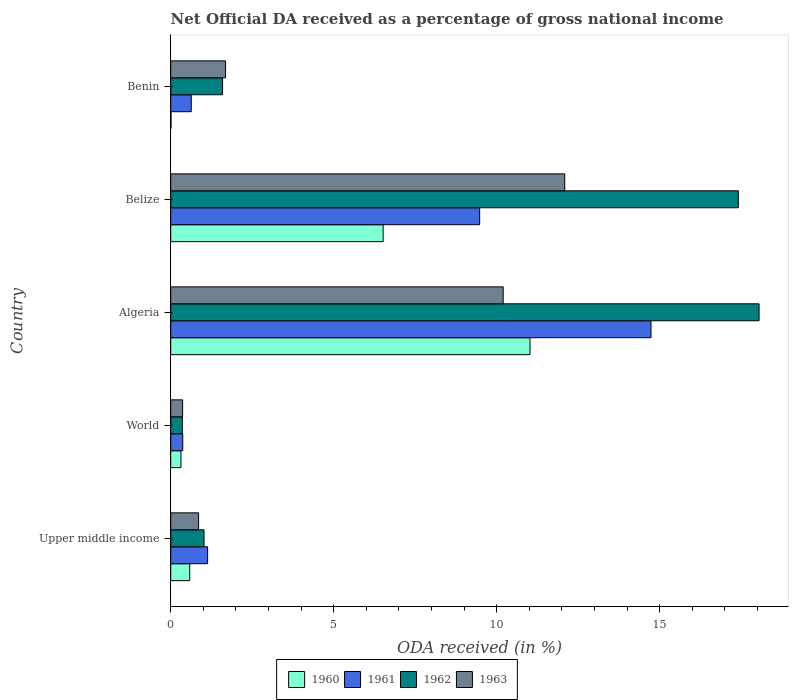How many different coloured bars are there?
Offer a terse response. 4. How many groups of bars are there?
Your response must be concise. 5. Are the number of bars on each tick of the Y-axis equal?
Provide a succinct answer. Yes. How many bars are there on the 3rd tick from the top?
Your response must be concise. 4. What is the label of the 2nd group of bars from the top?
Keep it short and to the point. Belize. What is the net official DA received in 1962 in Benin?
Make the answer very short. 1.59. Across all countries, what is the maximum net official DA received in 1963?
Ensure brevity in your answer.  12.09. Across all countries, what is the minimum net official DA received in 1961?
Offer a terse response. 0.37. In which country was the net official DA received in 1961 maximum?
Offer a terse response. Algeria. What is the total net official DA received in 1961 in the graph?
Your answer should be compact. 26.34. What is the difference between the net official DA received in 1960 in Upper middle income and that in World?
Make the answer very short. 0.27. What is the difference between the net official DA received in 1961 in Belize and the net official DA received in 1960 in Upper middle income?
Ensure brevity in your answer.  8.89. What is the average net official DA received in 1961 per country?
Give a very brief answer. 5.27. What is the difference between the net official DA received in 1962 and net official DA received in 1961 in World?
Offer a very short reply. -0.01. What is the ratio of the net official DA received in 1960 in Benin to that in World?
Keep it short and to the point. 0.03. Is the net official DA received in 1963 in Benin less than that in World?
Give a very brief answer. No. What is the difference between the highest and the second highest net official DA received in 1961?
Provide a short and direct response. 5.26. What is the difference between the highest and the lowest net official DA received in 1962?
Provide a succinct answer. 17.69. In how many countries, is the net official DA received in 1962 greater than the average net official DA received in 1962 taken over all countries?
Your answer should be compact. 2. Is the sum of the net official DA received in 1962 in Belize and World greater than the maximum net official DA received in 1963 across all countries?
Keep it short and to the point. Yes. Is it the case that in every country, the sum of the net official DA received in 1960 and net official DA received in 1962 is greater than the sum of net official DA received in 1961 and net official DA received in 1963?
Provide a succinct answer. No. What does the 1st bar from the top in World represents?
Give a very brief answer. 1963. Are all the bars in the graph horizontal?
Your response must be concise. Yes. How many countries are there in the graph?
Offer a terse response. 5. What is the difference between two consecutive major ticks on the X-axis?
Provide a short and direct response. 5. What is the title of the graph?
Your answer should be compact. Net Official DA received as a percentage of gross national income. What is the label or title of the X-axis?
Ensure brevity in your answer.  ODA received (in %). What is the ODA received (in %) in 1960 in Upper middle income?
Provide a short and direct response. 0.58. What is the ODA received (in %) in 1961 in Upper middle income?
Your answer should be very brief. 1.13. What is the ODA received (in %) of 1962 in Upper middle income?
Ensure brevity in your answer.  1.02. What is the ODA received (in %) of 1963 in Upper middle income?
Give a very brief answer. 0.86. What is the ODA received (in %) in 1960 in World?
Keep it short and to the point. 0.31. What is the ODA received (in %) in 1961 in World?
Your answer should be very brief. 0.37. What is the ODA received (in %) of 1962 in World?
Provide a succinct answer. 0.36. What is the ODA received (in %) of 1963 in World?
Offer a terse response. 0.36. What is the ODA received (in %) of 1960 in Algeria?
Your answer should be compact. 11.02. What is the ODA received (in %) in 1961 in Algeria?
Offer a very short reply. 14.73. What is the ODA received (in %) of 1962 in Algeria?
Your answer should be compact. 18.05. What is the ODA received (in %) in 1963 in Algeria?
Offer a terse response. 10.2. What is the ODA received (in %) of 1960 in Belize?
Make the answer very short. 6.52. What is the ODA received (in %) of 1961 in Belize?
Your answer should be very brief. 9.48. What is the ODA received (in %) of 1962 in Belize?
Your response must be concise. 17.41. What is the ODA received (in %) of 1963 in Belize?
Keep it short and to the point. 12.09. What is the ODA received (in %) in 1960 in Benin?
Provide a succinct answer. 0.01. What is the ODA received (in %) in 1961 in Benin?
Offer a terse response. 0.63. What is the ODA received (in %) in 1962 in Benin?
Offer a terse response. 1.59. What is the ODA received (in %) in 1963 in Benin?
Offer a terse response. 1.68. Across all countries, what is the maximum ODA received (in %) of 1960?
Your response must be concise. 11.02. Across all countries, what is the maximum ODA received (in %) of 1961?
Keep it short and to the point. 14.73. Across all countries, what is the maximum ODA received (in %) of 1962?
Provide a short and direct response. 18.05. Across all countries, what is the maximum ODA received (in %) in 1963?
Your response must be concise. 12.09. Across all countries, what is the minimum ODA received (in %) in 1960?
Offer a very short reply. 0.01. Across all countries, what is the minimum ODA received (in %) of 1961?
Make the answer very short. 0.37. Across all countries, what is the minimum ODA received (in %) of 1962?
Your answer should be compact. 0.36. Across all countries, what is the minimum ODA received (in %) of 1963?
Ensure brevity in your answer.  0.36. What is the total ODA received (in %) of 1960 in the graph?
Provide a short and direct response. 18.44. What is the total ODA received (in %) in 1961 in the graph?
Your answer should be compact. 26.34. What is the total ODA received (in %) of 1962 in the graph?
Your answer should be compact. 38.43. What is the total ODA received (in %) in 1963 in the graph?
Offer a terse response. 25.19. What is the difference between the ODA received (in %) of 1960 in Upper middle income and that in World?
Ensure brevity in your answer.  0.27. What is the difference between the ODA received (in %) in 1961 in Upper middle income and that in World?
Offer a very short reply. 0.76. What is the difference between the ODA received (in %) of 1962 in Upper middle income and that in World?
Your answer should be compact. 0.66. What is the difference between the ODA received (in %) of 1963 in Upper middle income and that in World?
Your answer should be compact. 0.49. What is the difference between the ODA received (in %) of 1960 in Upper middle income and that in Algeria?
Your answer should be very brief. -10.44. What is the difference between the ODA received (in %) of 1961 in Upper middle income and that in Algeria?
Your response must be concise. -13.6. What is the difference between the ODA received (in %) of 1962 in Upper middle income and that in Algeria?
Make the answer very short. -17.03. What is the difference between the ODA received (in %) of 1963 in Upper middle income and that in Algeria?
Your answer should be compact. -9.34. What is the difference between the ODA received (in %) in 1960 in Upper middle income and that in Belize?
Keep it short and to the point. -5.93. What is the difference between the ODA received (in %) of 1961 in Upper middle income and that in Belize?
Make the answer very short. -8.35. What is the difference between the ODA received (in %) in 1962 in Upper middle income and that in Belize?
Your answer should be very brief. -16.39. What is the difference between the ODA received (in %) in 1963 in Upper middle income and that in Belize?
Offer a terse response. -11.23. What is the difference between the ODA received (in %) in 1960 in Upper middle income and that in Benin?
Offer a very short reply. 0.58. What is the difference between the ODA received (in %) in 1961 in Upper middle income and that in Benin?
Your answer should be compact. 0.5. What is the difference between the ODA received (in %) of 1962 in Upper middle income and that in Benin?
Give a very brief answer. -0.57. What is the difference between the ODA received (in %) in 1963 in Upper middle income and that in Benin?
Provide a succinct answer. -0.83. What is the difference between the ODA received (in %) in 1960 in World and that in Algeria?
Your answer should be very brief. -10.71. What is the difference between the ODA received (in %) in 1961 in World and that in Algeria?
Make the answer very short. -14.36. What is the difference between the ODA received (in %) in 1962 in World and that in Algeria?
Your answer should be very brief. -17.69. What is the difference between the ODA received (in %) in 1963 in World and that in Algeria?
Give a very brief answer. -9.83. What is the difference between the ODA received (in %) of 1960 in World and that in Belize?
Provide a short and direct response. -6.2. What is the difference between the ODA received (in %) in 1961 in World and that in Belize?
Keep it short and to the point. -9.11. What is the difference between the ODA received (in %) of 1962 in World and that in Belize?
Provide a short and direct response. -17.05. What is the difference between the ODA received (in %) in 1963 in World and that in Belize?
Ensure brevity in your answer.  -11.72. What is the difference between the ODA received (in %) in 1960 in World and that in Benin?
Keep it short and to the point. 0.31. What is the difference between the ODA received (in %) in 1961 in World and that in Benin?
Offer a terse response. -0.26. What is the difference between the ODA received (in %) of 1962 in World and that in Benin?
Your response must be concise. -1.23. What is the difference between the ODA received (in %) of 1963 in World and that in Benin?
Offer a terse response. -1.32. What is the difference between the ODA received (in %) in 1960 in Algeria and that in Belize?
Your answer should be very brief. 4.51. What is the difference between the ODA received (in %) of 1961 in Algeria and that in Belize?
Your answer should be compact. 5.26. What is the difference between the ODA received (in %) in 1962 in Algeria and that in Belize?
Your answer should be compact. 0.64. What is the difference between the ODA received (in %) in 1963 in Algeria and that in Belize?
Offer a terse response. -1.89. What is the difference between the ODA received (in %) of 1960 in Algeria and that in Benin?
Make the answer very short. 11.01. What is the difference between the ODA received (in %) in 1961 in Algeria and that in Benin?
Provide a succinct answer. 14.1. What is the difference between the ODA received (in %) of 1962 in Algeria and that in Benin?
Keep it short and to the point. 16.46. What is the difference between the ODA received (in %) of 1963 in Algeria and that in Benin?
Provide a short and direct response. 8.52. What is the difference between the ODA received (in %) in 1960 in Belize and that in Benin?
Your response must be concise. 6.51. What is the difference between the ODA received (in %) of 1961 in Belize and that in Benin?
Your answer should be compact. 8.85. What is the difference between the ODA received (in %) in 1962 in Belize and that in Benin?
Your answer should be compact. 15.82. What is the difference between the ODA received (in %) of 1963 in Belize and that in Benin?
Offer a very short reply. 10.4. What is the difference between the ODA received (in %) of 1960 in Upper middle income and the ODA received (in %) of 1961 in World?
Provide a short and direct response. 0.21. What is the difference between the ODA received (in %) of 1960 in Upper middle income and the ODA received (in %) of 1962 in World?
Keep it short and to the point. 0.23. What is the difference between the ODA received (in %) in 1960 in Upper middle income and the ODA received (in %) in 1963 in World?
Your answer should be compact. 0.22. What is the difference between the ODA received (in %) in 1961 in Upper middle income and the ODA received (in %) in 1962 in World?
Offer a very short reply. 0.77. What is the difference between the ODA received (in %) in 1961 in Upper middle income and the ODA received (in %) in 1963 in World?
Offer a very short reply. 0.77. What is the difference between the ODA received (in %) of 1962 in Upper middle income and the ODA received (in %) of 1963 in World?
Provide a succinct answer. 0.66. What is the difference between the ODA received (in %) of 1960 in Upper middle income and the ODA received (in %) of 1961 in Algeria?
Offer a terse response. -14.15. What is the difference between the ODA received (in %) in 1960 in Upper middle income and the ODA received (in %) in 1962 in Algeria?
Your answer should be very brief. -17.46. What is the difference between the ODA received (in %) of 1960 in Upper middle income and the ODA received (in %) of 1963 in Algeria?
Ensure brevity in your answer.  -9.61. What is the difference between the ODA received (in %) in 1961 in Upper middle income and the ODA received (in %) in 1962 in Algeria?
Offer a very short reply. -16.92. What is the difference between the ODA received (in %) of 1961 in Upper middle income and the ODA received (in %) of 1963 in Algeria?
Provide a succinct answer. -9.07. What is the difference between the ODA received (in %) in 1962 in Upper middle income and the ODA received (in %) in 1963 in Algeria?
Your answer should be compact. -9.18. What is the difference between the ODA received (in %) of 1960 in Upper middle income and the ODA received (in %) of 1961 in Belize?
Provide a succinct answer. -8.89. What is the difference between the ODA received (in %) of 1960 in Upper middle income and the ODA received (in %) of 1962 in Belize?
Give a very brief answer. -16.83. What is the difference between the ODA received (in %) in 1960 in Upper middle income and the ODA received (in %) in 1963 in Belize?
Your answer should be very brief. -11.5. What is the difference between the ODA received (in %) in 1961 in Upper middle income and the ODA received (in %) in 1962 in Belize?
Offer a very short reply. -16.28. What is the difference between the ODA received (in %) in 1961 in Upper middle income and the ODA received (in %) in 1963 in Belize?
Offer a terse response. -10.96. What is the difference between the ODA received (in %) of 1962 in Upper middle income and the ODA received (in %) of 1963 in Belize?
Provide a short and direct response. -11.07. What is the difference between the ODA received (in %) of 1960 in Upper middle income and the ODA received (in %) of 1961 in Benin?
Provide a short and direct response. -0.05. What is the difference between the ODA received (in %) in 1960 in Upper middle income and the ODA received (in %) in 1962 in Benin?
Provide a short and direct response. -1.01. What is the difference between the ODA received (in %) of 1960 in Upper middle income and the ODA received (in %) of 1963 in Benin?
Your answer should be compact. -1.1. What is the difference between the ODA received (in %) in 1961 in Upper middle income and the ODA received (in %) in 1962 in Benin?
Provide a succinct answer. -0.46. What is the difference between the ODA received (in %) in 1961 in Upper middle income and the ODA received (in %) in 1963 in Benin?
Make the answer very short. -0.55. What is the difference between the ODA received (in %) of 1962 in Upper middle income and the ODA received (in %) of 1963 in Benin?
Your response must be concise. -0.66. What is the difference between the ODA received (in %) of 1960 in World and the ODA received (in %) of 1961 in Algeria?
Keep it short and to the point. -14.42. What is the difference between the ODA received (in %) of 1960 in World and the ODA received (in %) of 1962 in Algeria?
Make the answer very short. -17.73. What is the difference between the ODA received (in %) of 1960 in World and the ODA received (in %) of 1963 in Algeria?
Provide a succinct answer. -9.88. What is the difference between the ODA received (in %) in 1961 in World and the ODA received (in %) in 1962 in Algeria?
Give a very brief answer. -17.68. What is the difference between the ODA received (in %) of 1961 in World and the ODA received (in %) of 1963 in Algeria?
Provide a short and direct response. -9.83. What is the difference between the ODA received (in %) in 1962 in World and the ODA received (in %) in 1963 in Algeria?
Offer a very short reply. -9.84. What is the difference between the ODA received (in %) of 1960 in World and the ODA received (in %) of 1961 in Belize?
Provide a short and direct response. -9.16. What is the difference between the ODA received (in %) in 1960 in World and the ODA received (in %) in 1962 in Belize?
Your answer should be compact. -17.1. What is the difference between the ODA received (in %) in 1960 in World and the ODA received (in %) in 1963 in Belize?
Ensure brevity in your answer.  -11.77. What is the difference between the ODA received (in %) in 1961 in World and the ODA received (in %) in 1962 in Belize?
Your answer should be very brief. -17.04. What is the difference between the ODA received (in %) in 1961 in World and the ODA received (in %) in 1963 in Belize?
Keep it short and to the point. -11.72. What is the difference between the ODA received (in %) in 1962 in World and the ODA received (in %) in 1963 in Belize?
Your response must be concise. -11.73. What is the difference between the ODA received (in %) in 1960 in World and the ODA received (in %) in 1961 in Benin?
Keep it short and to the point. -0.32. What is the difference between the ODA received (in %) of 1960 in World and the ODA received (in %) of 1962 in Benin?
Provide a short and direct response. -1.28. What is the difference between the ODA received (in %) in 1960 in World and the ODA received (in %) in 1963 in Benin?
Keep it short and to the point. -1.37. What is the difference between the ODA received (in %) in 1961 in World and the ODA received (in %) in 1962 in Benin?
Ensure brevity in your answer.  -1.22. What is the difference between the ODA received (in %) of 1961 in World and the ODA received (in %) of 1963 in Benin?
Make the answer very short. -1.31. What is the difference between the ODA received (in %) in 1962 in World and the ODA received (in %) in 1963 in Benin?
Your response must be concise. -1.32. What is the difference between the ODA received (in %) of 1960 in Algeria and the ODA received (in %) of 1961 in Belize?
Your response must be concise. 1.54. What is the difference between the ODA received (in %) in 1960 in Algeria and the ODA received (in %) in 1962 in Belize?
Provide a short and direct response. -6.39. What is the difference between the ODA received (in %) of 1960 in Algeria and the ODA received (in %) of 1963 in Belize?
Your response must be concise. -1.07. What is the difference between the ODA received (in %) of 1961 in Algeria and the ODA received (in %) of 1962 in Belize?
Offer a terse response. -2.68. What is the difference between the ODA received (in %) of 1961 in Algeria and the ODA received (in %) of 1963 in Belize?
Offer a very short reply. 2.65. What is the difference between the ODA received (in %) in 1962 in Algeria and the ODA received (in %) in 1963 in Belize?
Make the answer very short. 5.96. What is the difference between the ODA received (in %) in 1960 in Algeria and the ODA received (in %) in 1961 in Benin?
Give a very brief answer. 10.39. What is the difference between the ODA received (in %) in 1960 in Algeria and the ODA received (in %) in 1962 in Benin?
Make the answer very short. 9.43. What is the difference between the ODA received (in %) of 1960 in Algeria and the ODA received (in %) of 1963 in Benin?
Keep it short and to the point. 9.34. What is the difference between the ODA received (in %) of 1961 in Algeria and the ODA received (in %) of 1962 in Benin?
Your answer should be very brief. 13.14. What is the difference between the ODA received (in %) of 1961 in Algeria and the ODA received (in %) of 1963 in Benin?
Make the answer very short. 13.05. What is the difference between the ODA received (in %) of 1962 in Algeria and the ODA received (in %) of 1963 in Benin?
Make the answer very short. 16.37. What is the difference between the ODA received (in %) of 1960 in Belize and the ODA received (in %) of 1961 in Benin?
Your answer should be compact. 5.89. What is the difference between the ODA received (in %) in 1960 in Belize and the ODA received (in %) in 1962 in Benin?
Your answer should be compact. 4.92. What is the difference between the ODA received (in %) in 1960 in Belize and the ODA received (in %) in 1963 in Benin?
Ensure brevity in your answer.  4.83. What is the difference between the ODA received (in %) of 1961 in Belize and the ODA received (in %) of 1962 in Benin?
Provide a short and direct response. 7.89. What is the difference between the ODA received (in %) of 1961 in Belize and the ODA received (in %) of 1963 in Benin?
Your answer should be compact. 7.79. What is the difference between the ODA received (in %) in 1962 in Belize and the ODA received (in %) in 1963 in Benin?
Ensure brevity in your answer.  15.73. What is the average ODA received (in %) in 1960 per country?
Make the answer very short. 3.69. What is the average ODA received (in %) of 1961 per country?
Make the answer very short. 5.27. What is the average ODA received (in %) in 1962 per country?
Provide a short and direct response. 7.69. What is the average ODA received (in %) in 1963 per country?
Provide a succinct answer. 5.04. What is the difference between the ODA received (in %) in 1960 and ODA received (in %) in 1961 in Upper middle income?
Offer a terse response. -0.55. What is the difference between the ODA received (in %) of 1960 and ODA received (in %) of 1962 in Upper middle income?
Make the answer very short. -0.44. What is the difference between the ODA received (in %) in 1960 and ODA received (in %) in 1963 in Upper middle income?
Make the answer very short. -0.27. What is the difference between the ODA received (in %) in 1961 and ODA received (in %) in 1962 in Upper middle income?
Provide a short and direct response. 0.11. What is the difference between the ODA received (in %) in 1961 and ODA received (in %) in 1963 in Upper middle income?
Give a very brief answer. 0.28. What is the difference between the ODA received (in %) in 1962 and ODA received (in %) in 1963 in Upper middle income?
Your answer should be very brief. 0.17. What is the difference between the ODA received (in %) of 1960 and ODA received (in %) of 1961 in World?
Offer a terse response. -0.06. What is the difference between the ODA received (in %) of 1960 and ODA received (in %) of 1962 in World?
Your answer should be compact. -0.04. What is the difference between the ODA received (in %) in 1960 and ODA received (in %) in 1963 in World?
Offer a very short reply. -0.05. What is the difference between the ODA received (in %) in 1961 and ODA received (in %) in 1962 in World?
Ensure brevity in your answer.  0.01. What is the difference between the ODA received (in %) in 1961 and ODA received (in %) in 1963 in World?
Your answer should be very brief. 0. What is the difference between the ODA received (in %) of 1962 and ODA received (in %) of 1963 in World?
Make the answer very short. -0.01. What is the difference between the ODA received (in %) of 1960 and ODA received (in %) of 1961 in Algeria?
Keep it short and to the point. -3.71. What is the difference between the ODA received (in %) in 1960 and ODA received (in %) in 1962 in Algeria?
Make the answer very short. -7.03. What is the difference between the ODA received (in %) in 1960 and ODA received (in %) in 1963 in Algeria?
Provide a succinct answer. 0.82. What is the difference between the ODA received (in %) in 1961 and ODA received (in %) in 1962 in Algeria?
Ensure brevity in your answer.  -3.31. What is the difference between the ODA received (in %) of 1961 and ODA received (in %) of 1963 in Algeria?
Your response must be concise. 4.54. What is the difference between the ODA received (in %) in 1962 and ODA received (in %) in 1963 in Algeria?
Your answer should be compact. 7.85. What is the difference between the ODA received (in %) of 1960 and ODA received (in %) of 1961 in Belize?
Your answer should be compact. -2.96. What is the difference between the ODA received (in %) in 1960 and ODA received (in %) in 1962 in Belize?
Make the answer very short. -10.9. What is the difference between the ODA received (in %) in 1960 and ODA received (in %) in 1963 in Belize?
Your response must be concise. -5.57. What is the difference between the ODA received (in %) of 1961 and ODA received (in %) of 1962 in Belize?
Your answer should be very brief. -7.93. What is the difference between the ODA received (in %) in 1961 and ODA received (in %) in 1963 in Belize?
Make the answer very short. -2.61. What is the difference between the ODA received (in %) in 1962 and ODA received (in %) in 1963 in Belize?
Offer a very short reply. 5.32. What is the difference between the ODA received (in %) of 1960 and ODA received (in %) of 1961 in Benin?
Offer a terse response. -0.62. What is the difference between the ODA received (in %) in 1960 and ODA received (in %) in 1962 in Benin?
Ensure brevity in your answer.  -1.58. What is the difference between the ODA received (in %) in 1960 and ODA received (in %) in 1963 in Benin?
Ensure brevity in your answer.  -1.67. What is the difference between the ODA received (in %) in 1961 and ODA received (in %) in 1962 in Benin?
Offer a terse response. -0.96. What is the difference between the ODA received (in %) of 1961 and ODA received (in %) of 1963 in Benin?
Provide a succinct answer. -1.05. What is the difference between the ODA received (in %) in 1962 and ODA received (in %) in 1963 in Benin?
Make the answer very short. -0.09. What is the ratio of the ODA received (in %) of 1960 in Upper middle income to that in World?
Ensure brevity in your answer.  1.86. What is the ratio of the ODA received (in %) in 1961 in Upper middle income to that in World?
Provide a short and direct response. 3.06. What is the ratio of the ODA received (in %) of 1962 in Upper middle income to that in World?
Give a very brief answer. 2.85. What is the ratio of the ODA received (in %) of 1963 in Upper middle income to that in World?
Make the answer very short. 2.34. What is the ratio of the ODA received (in %) of 1960 in Upper middle income to that in Algeria?
Ensure brevity in your answer.  0.05. What is the ratio of the ODA received (in %) in 1961 in Upper middle income to that in Algeria?
Offer a terse response. 0.08. What is the ratio of the ODA received (in %) of 1962 in Upper middle income to that in Algeria?
Give a very brief answer. 0.06. What is the ratio of the ODA received (in %) of 1963 in Upper middle income to that in Algeria?
Your answer should be compact. 0.08. What is the ratio of the ODA received (in %) in 1960 in Upper middle income to that in Belize?
Offer a terse response. 0.09. What is the ratio of the ODA received (in %) of 1961 in Upper middle income to that in Belize?
Your response must be concise. 0.12. What is the ratio of the ODA received (in %) of 1962 in Upper middle income to that in Belize?
Offer a terse response. 0.06. What is the ratio of the ODA received (in %) of 1963 in Upper middle income to that in Belize?
Your answer should be compact. 0.07. What is the ratio of the ODA received (in %) of 1960 in Upper middle income to that in Benin?
Provide a succinct answer. 65.83. What is the ratio of the ODA received (in %) in 1961 in Upper middle income to that in Benin?
Offer a very short reply. 1.8. What is the ratio of the ODA received (in %) in 1962 in Upper middle income to that in Benin?
Your answer should be very brief. 0.64. What is the ratio of the ODA received (in %) of 1963 in Upper middle income to that in Benin?
Your response must be concise. 0.51. What is the ratio of the ODA received (in %) of 1960 in World to that in Algeria?
Provide a succinct answer. 0.03. What is the ratio of the ODA received (in %) of 1961 in World to that in Algeria?
Offer a very short reply. 0.03. What is the ratio of the ODA received (in %) in 1962 in World to that in Algeria?
Make the answer very short. 0.02. What is the ratio of the ODA received (in %) of 1963 in World to that in Algeria?
Provide a succinct answer. 0.04. What is the ratio of the ODA received (in %) in 1960 in World to that in Belize?
Ensure brevity in your answer.  0.05. What is the ratio of the ODA received (in %) of 1961 in World to that in Belize?
Keep it short and to the point. 0.04. What is the ratio of the ODA received (in %) of 1962 in World to that in Belize?
Your answer should be compact. 0.02. What is the ratio of the ODA received (in %) of 1963 in World to that in Belize?
Make the answer very short. 0.03. What is the ratio of the ODA received (in %) in 1960 in World to that in Benin?
Make the answer very short. 35.46. What is the ratio of the ODA received (in %) in 1961 in World to that in Benin?
Offer a terse response. 0.59. What is the ratio of the ODA received (in %) of 1962 in World to that in Benin?
Your answer should be compact. 0.23. What is the ratio of the ODA received (in %) in 1963 in World to that in Benin?
Keep it short and to the point. 0.22. What is the ratio of the ODA received (in %) of 1960 in Algeria to that in Belize?
Offer a very short reply. 1.69. What is the ratio of the ODA received (in %) of 1961 in Algeria to that in Belize?
Ensure brevity in your answer.  1.55. What is the ratio of the ODA received (in %) in 1962 in Algeria to that in Belize?
Give a very brief answer. 1.04. What is the ratio of the ODA received (in %) in 1963 in Algeria to that in Belize?
Your response must be concise. 0.84. What is the ratio of the ODA received (in %) in 1960 in Algeria to that in Benin?
Your response must be concise. 1242.53. What is the ratio of the ODA received (in %) of 1961 in Algeria to that in Benin?
Ensure brevity in your answer.  23.39. What is the ratio of the ODA received (in %) of 1962 in Algeria to that in Benin?
Provide a succinct answer. 11.34. What is the ratio of the ODA received (in %) of 1963 in Algeria to that in Benin?
Keep it short and to the point. 6.06. What is the ratio of the ODA received (in %) in 1960 in Belize to that in Benin?
Your answer should be compact. 734.62. What is the ratio of the ODA received (in %) of 1961 in Belize to that in Benin?
Your response must be concise. 15.04. What is the ratio of the ODA received (in %) in 1962 in Belize to that in Benin?
Keep it short and to the point. 10.94. What is the ratio of the ODA received (in %) in 1963 in Belize to that in Benin?
Provide a short and direct response. 7.18. What is the difference between the highest and the second highest ODA received (in %) of 1960?
Ensure brevity in your answer.  4.51. What is the difference between the highest and the second highest ODA received (in %) of 1961?
Make the answer very short. 5.26. What is the difference between the highest and the second highest ODA received (in %) of 1962?
Keep it short and to the point. 0.64. What is the difference between the highest and the second highest ODA received (in %) in 1963?
Provide a short and direct response. 1.89. What is the difference between the highest and the lowest ODA received (in %) in 1960?
Offer a very short reply. 11.01. What is the difference between the highest and the lowest ODA received (in %) in 1961?
Make the answer very short. 14.36. What is the difference between the highest and the lowest ODA received (in %) of 1962?
Your response must be concise. 17.69. What is the difference between the highest and the lowest ODA received (in %) in 1963?
Offer a very short reply. 11.72. 